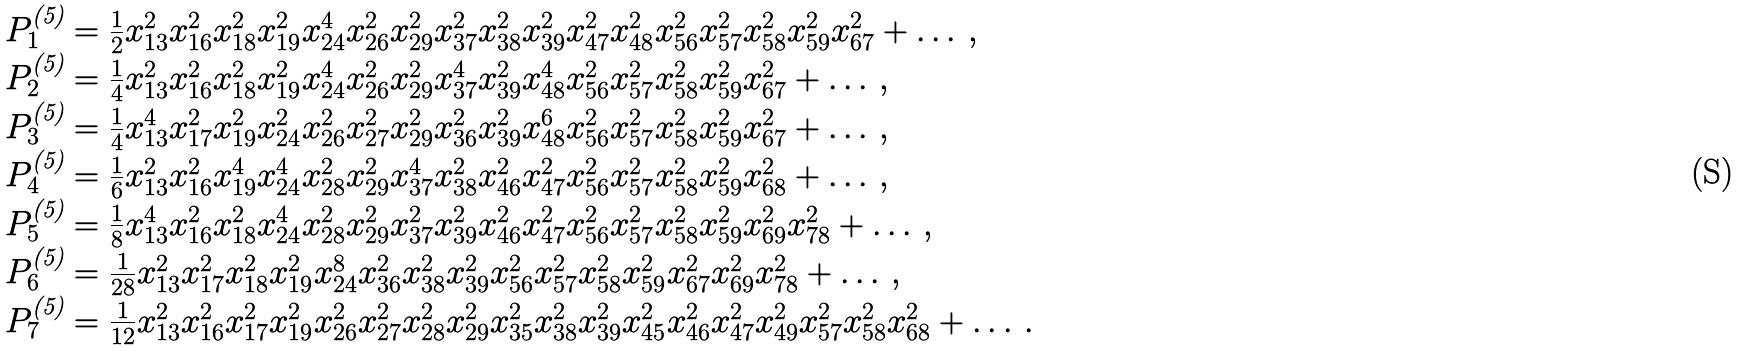<formula> <loc_0><loc_0><loc_500><loc_500>\begin{array} { l } P _ { 1 } ^ { \text {(5)} } = \frac { 1 } { 2 } x _ { 1 3 } ^ { 2 } x _ { 1 6 } ^ { 2 } x _ { 1 8 } ^ { 2 } x _ { 1 9 } ^ { 2 } x _ { 2 4 } ^ { 4 } x _ { 2 6 } ^ { 2 } x _ { 2 9 } ^ { 2 } x _ { 3 7 } ^ { 2 } x _ { 3 8 } ^ { 2 } x _ { 3 9 } ^ { 2 } x _ { 4 7 } ^ { 2 } x _ { 4 8 } ^ { 2 } x _ { 5 6 } ^ { 2 } x _ { 5 7 } ^ { 2 } x _ { 5 8 } ^ { 2 } x _ { 5 9 } ^ { 2 } x _ { 6 7 } ^ { 2 } + \dots \, , \\ P _ { 2 } ^ { \text {(5)} } = \frac { 1 } { 4 } x _ { 1 3 } ^ { 2 } x _ { 1 6 } ^ { 2 } x _ { 1 8 } ^ { 2 } x _ { 1 9 } ^ { 2 } x _ { 2 4 } ^ { 4 } x _ { 2 6 } ^ { 2 } x _ { 2 9 } ^ { 2 } x _ { 3 7 } ^ { 4 } x _ { 3 9 } ^ { 2 } x _ { 4 8 } ^ { 4 } x _ { 5 6 } ^ { 2 } x _ { 5 7 } ^ { 2 } x _ { 5 8 } ^ { 2 } x _ { 5 9 } ^ { 2 } x _ { 6 7 } ^ { 2 } + \dots \, , \\ P _ { 3 } ^ { \text {(5)} } = \frac { 1 } { 4 } x _ { 1 3 } ^ { 4 } x _ { 1 7 } ^ { 2 } x _ { 1 9 } ^ { 2 } x _ { 2 4 } ^ { 2 } x _ { 2 6 } ^ { 2 } x _ { 2 7 } ^ { 2 } x _ { 2 9 } ^ { 2 } x _ { 3 6 } ^ { 2 } x _ { 3 9 } ^ { 2 } x _ { 4 8 } ^ { 6 } x _ { 5 6 } ^ { 2 } x _ { 5 7 } ^ { 2 } x _ { 5 8 } ^ { 2 } x _ { 5 9 } ^ { 2 } x _ { 6 7 } ^ { 2 } + \dots \, , \\ P _ { 4 } ^ { \text {(5)} } = \frac { 1 } { 6 } x _ { 1 3 } ^ { 2 } x _ { 1 6 } ^ { 2 } x _ { 1 9 } ^ { 4 } x _ { 2 4 } ^ { 4 } x _ { 2 8 } ^ { 2 } x _ { 2 9 } ^ { 2 } x _ { 3 7 } ^ { 4 } x _ { 3 8 } ^ { 2 } x _ { 4 6 } ^ { 2 } x _ { 4 7 } ^ { 2 } x _ { 5 6 } ^ { 2 } x _ { 5 7 } ^ { 2 } x _ { 5 8 } ^ { 2 } x _ { 5 9 } ^ { 2 } x _ { 6 8 } ^ { 2 } + \dots \, , \\ P _ { 5 } ^ { \text {(5)} } = \frac { 1 } { 8 } x _ { 1 3 } ^ { 4 } x _ { 1 6 } ^ { 2 } x _ { 1 8 } ^ { 2 } x _ { 2 4 } ^ { 4 } x _ { 2 8 } ^ { 2 } x _ { 2 9 } ^ { 2 } x _ { 3 7 } ^ { 2 } x _ { 3 9 } ^ { 2 } x _ { 4 6 } ^ { 2 } x _ { 4 7 } ^ { 2 } x _ { 5 6 } ^ { 2 } x _ { 5 7 } ^ { 2 } x _ { 5 8 } ^ { 2 } x _ { 5 9 } ^ { 2 } x _ { 6 9 } ^ { 2 } x _ { 7 8 } ^ { 2 } + \dots \, , \\ P _ { 6 } ^ { \text {(5)} } = \frac { 1 } { 2 8 } x _ { 1 3 } ^ { 2 } x _ { 1 7 } ^ { 2 } x _ { 1 8 } ^ { 2 } x _ { 1 9 } ^ { 2 } x _ { 2 4 } ^ { 8 } x _ { 3 6 } ^ { 2 } x _ { 3 8 } ^ { 2 } x _ { 3 9 } ^ { 2 } x _ { 5 6 } ^ { 2 } x _ { 5 7 } ^ { 2 } x _ { 5 8 } ^ { 2 } x _ { 5 9 } ^ { 2 } x _ { 6 7 } ^ { 2 } x _ { 6 9 } ^ { 2 } x _ { 7 8 } ^ { 2 } + \dots \, , \\ P _ { 7 } ^ { \text {(5)} } = \frac { 1 } { 1 2 } x _ { 1 3 } ^ { 2 } x _ { 1 6 } ^ { 2 } x _ { 1 7 } ^ { 2 } x _ { 1 9 } ^ { 2 } x _ { 2 6 } ^ { 2 } x _ { 2 7 } ^ { 2 } x _ { 2 8 } ^ { 2 } x _ { 2 9 } ^ { 2 } x _ { 3 5 } ^ { 2 } x _ { 3 8 } ^ { 2 } x _ { 3 9 } ^ { 2 } x _ { 4 5 } ^ { 2 } x _ { 4 6 } ^ { 2 } x _ { 4 7 } ^ { 2 } x _ { 4 9 } ^ { 2 } x _ { 5 7 } ^ { 2 } x _ { 5 8 } ^ { 2 } x _ { 6 8 } ^ { 2 } + \dots \, . \end{array}</formula> 